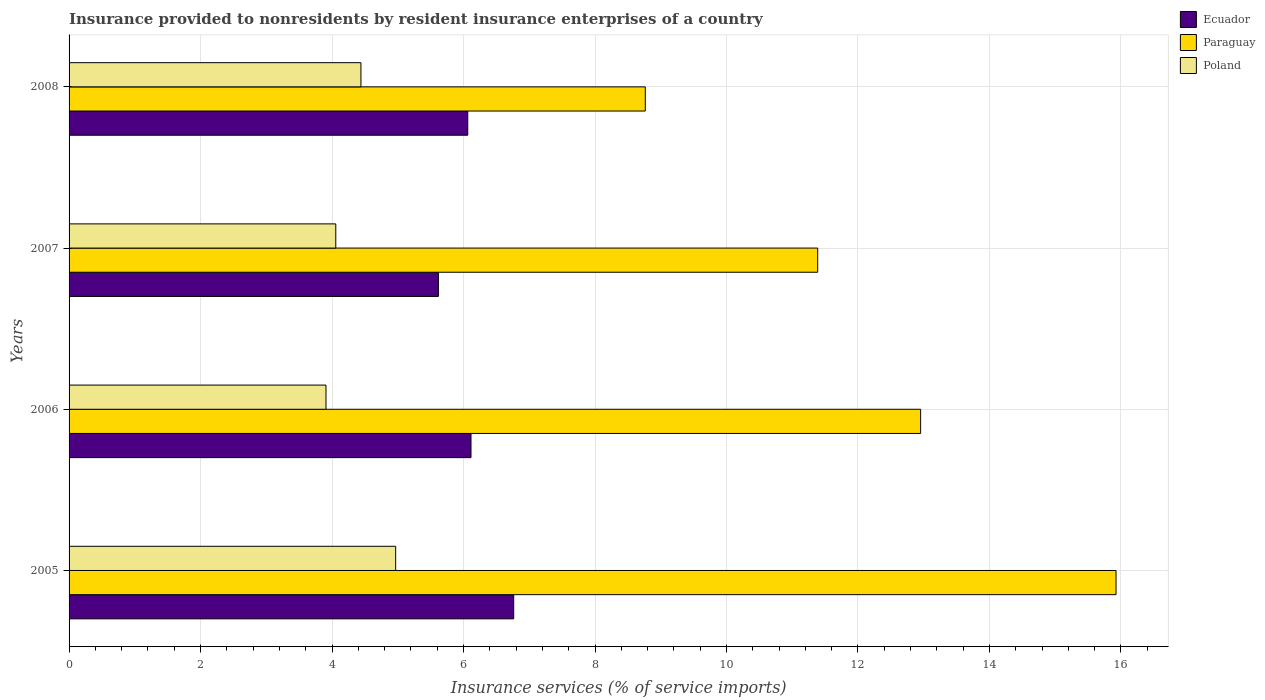How many different coloured bars are there?
Make the answer very short. 3. Are the number of bars on each tick of the Y-axis equal?
Offer a very short reply. Yes. How many bars are there on the 2nd tick from the top?
Ensure brevity in your answer.  3. What is the label of the 3rd group of bars from the top?
Your answer should be compact. 2006. In how many cases, is the number of bars for a given year not equal to the number of legend labels?
Keep it short and to the point. 0. What is the insurance provided to nonresidents in Paraguay in 2007?
Provide a succinct answer. 11.39. Across all years, what is the maximum insurance provided to nonresidents in Poland?
Give a very brief answer. 4.97. Across all years, what is the minimum insurance provided to nonresidents in Poland?
Offer a very short reply. 3.91. In which year was the insurance provided to nonresidents in Poland maximum?
Your response must be concise. 2005. What is the total insurance provided to nonresidents in Poland in the graph?
Your answer should be compact. 17.37. What is the difference between the insurance provided to nonresidents in Poland in 2006 and that in 2007?
Ensure brevity in your answer.  -0.15. What is the difference between the insurance provided to nonresidents in Poland in 2006 and the insurance provided to nonresidents in Paraguay in 2005?
Offer a terse response. -12.02. What is the average insurance provided to nonresidents in Ecuador per year?
Offer a terse response. 6.14. In the year 2008, what is the difference between the insurance provided to nonresidents in Poland and insurance provided to nonresidents in Paraguay?
Your answer should be very brief. -4.33. In how many years, is the insurance provided to nonresidents in Paraguay greater than 16 %?
Provide a succinct answer. 0. What is the ratio of the insurance provided to nonresidents in Ecuador in 2005 to that in 2006?
Ensure brevity in your answer.  1.11. Is the difference between the insurance provided to nonresidents in Poland in 2005 and 2006 greater than the difference between the insurance provided to nonresidents in Paraguay in 2005 and 2006?
Offer a terse response. No. What is the difference between the highest and the second highest insurance provided to nonresidents in Ecuador?
Give a very brief answer. 0.65. What is the difference between the highest and the lowest insurance provided to nonresidents in Ecuador?
Offer a terse response. 1.15. In how many years, is the insurance provided to nonresidents in Poland greater than the average insurance provided to nonresidents in Poland taken over all years?
Provide a short and direct response. 2. What does the 3rd bar from the top in 2007 represents?
Ensure brevity in your answer.  Ecuador. What does the 3rd bar from the bottom in 2008 represents?
Make the answer very short. Poland. How many bars are there?
Your answer should be very brief. 12. Are all the bars in the graph horizontal?
Make the answer very short. Yes. What is the difference between two consecutive major ticks on the X-axis?
Keep it short and to the point. 2. Does the graph contain grids?
Provide a short and direct response. Yes. Where does the legend appear in the graph?
Your answer should be very brief. Top right. How many legend labels are there?
Offer a terse response. 3. How are the legend labels stacked?
Ensure brevity in your answer.  Vertical. What is the title of the graph?
Your answer should be very brief. Insurance provided to nonresidents by resident insurance enterprises of a country. What is the label or title of the X-axis?
Give a very brief answer. Insurance services (% of service imports). What is the Insurance services (% of service imports) of Ecuador in 2005?
Your answer should be compact. 6.76. What is the Insurance services (% of service imports) in Paraguay in 2005?
Ensure brevity in your answer.  15.93. What is the Insurance services (% of service imports) in Poland in 2005?
Keep it short and to the point. 4.97. What is the Insurance services (% of service imports) of Ecuador in 2006?
Make the answer very short. 6.11. What is the Insurance services (% of service imports) in Paraguay in 2006?
Your response must be concise. 12.95. What is the Insurance services (% of service imports) in Poland in 2006?
Provide a succinct answer. 3.91. What is the Insurance services (% of service imports) in Ecuador in 2007?
Give a very brief answer. 5.62. What is the Insurance services (% of service imports) of Paraguay in 2007?
Offer a terse response. 11.39. What is the Insurance services (% of service imports) of Poland in 2007?
Ensure brevity in your answer.  4.06. What is the Insurance services (% of service imports) of Ecuador in 2008?
Provide a succinct answer. 6.06. What is the Insurance services (% of service imports) in Paraguay in 2008?
Offer a very short reply. 8.77. What is the Insurance services (% of service imports) in Poland in 2008?
Provide a short and direct response. 4.44. Across all years, what is the maximum Insurance services (% of service imports) in Ecuador?
Your answer should be compact. 6.76. Across all years, what is the maximum Insurance services (% of service imports) of Paraguay?
Your answer should be very brief. 15.93. Across all years, what is the maximum Insurance services (% of service imports) in Poland?
Provide a short and direct response. 4.97. Across all years, what is the minimum Insurance services (% of service imports) in Ecuador?
Give a very brief answer. 5.62. Across all years, what is the minimum Insurance services (% of service imports) in Paraguay?
Keep it short and to the point. 8.77. Across all years, what is the minimum Insurance services (% of service imports) of Poland?
Provide a short and direct response. 3.91. What is the total Insurance services (% of service imports) of Ecuador in the graph?
Offer a terse response. 24.56. What is the total Insurance services (% of service imports) in Paraguay in the graph?
Ensure brevity in your answer.  49.03. What is the total Insurance services (% of service imports) in Poland in the graph?
Give a very brief answer. 17.37. What is the difference between the Insurance services (% of service imports) in Ecuador in 2005 and that in 2006?
Offer a terse response. 0.65. What is the difference between the Insurance services (% of service imports) of Paraguay in 2005 and that in 2006?
Ensure brevity in your answer.  2.97. What is the difference between the Insurance services (% of service imports) in Poland in 2005 and that in 2006?
Provide a short and direct response. 1.06. What is the difference between the Insurance services (% of service imports) in Ecuador in 2005 and that in 2007?
Make the answer very short. 1.15. What is the difference between the Insurance services (% of service imports) of Paraguay in 2005 and that in 2007?
Offer a terse response. 4.54. What is the difference between the Insurance services (% of service imports) in Poland in 2005 and that in 2007?
Offer a terse response. 0.91. What is the difference between the Insurance services (% of service imports) in Ecuador in 2005 and that in 2008?
Give a very brief answer. 0.7. What is the difference between the Insurance services (% of service imports) of Paraguay in 2005 and that in 2008?
Offer a terse response. 7.16. What is the difference between the Insurance services (% of service imports) of Poland in 2005 and that in 2008?
Your answer should be compact. 0.53. What is the difference between the Insurance services (% of service imports) of Ecuador in 2006 and that in 2007?
Ensure brevity in your answer.  0.5. What is the difference between the Insurance services (% of service imports) of Paraguay in 2006 and that in 2007?
Make the answer very short. 1.57. What is the difference between the Insurance services (% of service imports) in Poland in 2006 and that in 2007?
Provide a short and direct response. -0.15. What is the difference between the Insurance services (% of service imports) of Ecuador in 2006 and that in 2008?
Your answer should be compact. 0.05. What is the difference between the Insurance services (% of service imports) in Paraguay in 2006 and that in 2008?
Provide a short and direct response. 4.19. What is the difference between the Insurance services (% of service imports) in Poland in 2006 and that in 2008?
Keep it short and to the point. -0.53. What is the difference between the Insurance services (% of service imports) in Ecuador in 2007 and that in 2008?
Give a very brief answer. -0.45. What is the difference between the Insurance services (% of service imports) of Paraguay in 2007 and that in 2008?
Your answer should be compact. 2.62. What is the difference between the Insurance services (% of service imports) of Poland in 2007 and that in 2008?
Offer a terse response. -0.38. What is the difference between the Insurance services (% of service imports) of Ecuador in 2005 and the Insurance services (% of service imports) of Paraguay in 2006?
Your answer should be compact. -6.19. What is the difference between the Insurance services (% of service imports) in Ecuador in 2005 and the Insurance services (% of service imports) in Poland in 2006?
Provide a succinct answer. 2.86. What is the difference between the Insurance services (% of service imports) of Paraguay in 2005 and the Insurance services (% of service imports) of Poland in 2006?
Provide a succinct answer. 12.02. What is the difference between the Insurance services (% of service imports) of Ecuador in 2005 and the Insurance services (% of service imports) of Paraguay in 2007?
Your response must be concise. -4.62. What is the difference between the Insurance services (% of service imports) in Ecuador in 2005 and the Insurance services (% of service imports) in Poland in 2007?
Make the answer very short. 2.71. What is the difference between the Insurance services (% of service imports) in Paraguay in 2005 and the Insurance services (% of service imports) in Poland in 2007?
Give a very brief answer. 11.87. What is the difference between the Insurance services (% of service imports) of Ecuador in 2005 and the Insurance services (% of service imports) of Paraguay in 2008?
Your answer should be compact. -2. What is the difference between the Insurance services (% of service imports) in Ecuador in 2005 and the Insurance services (% of service imports) in Poland in 2008?
Your answer should be very brief. 2.32. What is the difference between the Insurance services (% of service imports) in Paraguay in 2005 and the Insurance services (% of service imports) in Poland in 2008?
Ensure brevity in your answer.  11.49. What is the difference between the Insurance services (% of service imports) in Ecuador in 2006 and the Insurance services (% of service imports) in Paraguay in 2007?
Your answer should be very brief. -5.27. What is the difference between the Insurance services (% of service imports) of Ecuador in 2006 and the Insurance services (% of service imports) of Poland in 2007?
Provide a succinct answer. 2.06. What is the difference between the Insurance services (% of service imports) in Paraguay in 2006 and the Insurance services (% of service imports) in Poland in 2007?
Offer a terse response. 8.9. What is the difference between the Insurance services (% of service imports) in Ecuador in 2006 and the Insurance services (% of service imports) in Paraguay in 2008?
Your answer should be compact. -2.65. What is the difference between the Insurance services (% of service imports) of Ecuador in 2006 and the Insurance services (% of service imports) of Poland in 2008?
Your response must be concise. 1.67. What is the difference between the Insurance services (% of service imports) in Paraguay in 2006 and the Insurance services (% of service imports) in Poland in 2008?
Offer a terse response. 8.51. What is the difference between the Insurance services (% of service imports) of Ecuador in 2007 and the Insurance services (% of service imports) of Paraguay in 2008?
Offer a terse response. -3.15. What is the difference between the Insurance services (% of service imports) in Ecuador in 2007 and the Insurance services (% of service imports) in Poland in 2008?
Keep it short and to the point. 1.18. What is the difference between the Insurance services (% of service imports) in Paraguay in 2007 and the Insurance services (% of service imports) in Poland in 2008?
Keep it short and to the point. 6.95. What is the average Insurance services (% of service imports) of Ecuador per year?
Your answer should be compact. 6.14. What is the average Insurance services (% of service imports) in Paraguay per year?
Offer a terse response. 12.26. What is the average Insurance services (% of service imports) of Poland per year?
Give a very brief answer. 4.34. In the year 2005, what is the difference between the Insurance services (% of service imports) of Ecuador and Insurance services (% of service imports) of Paraguay?
Your answer should be very brief. -9.16. In the year 2005, what is the difference between the Insurance services (% of service imports) of Ecuador and Insurance services (% of service imports) of Poland?
Provide a short and direct response. 1.8. In the year 2005, what is the difference between the Insurance services (% of service imports) of Paraguay and Insurance services (% of service imports) of Poland?
Your answer should be compact. 10.96. In the year 2006, what is the difference between the Insurance services (% of service imports) in Ecuador and Insurance services (% of service imports) in Paraguay?
Your answer should be very brief. -6.84. In the year 2006, what is the difference between the Insurance services (% of service imports) in Ecuador and Insurance services (% of service imports) in Poland?
Provide a short and direct response. 2.21. In the year 2006, what is the difference between the Insurance services (% of service imports) in Paraguay and Insurance services (% of service imports) in Poland?
Make the answer very short. 9.04. In the year 2007, what is the difference between the Insurance services (% of service imports) of Ecuador and Insurance services (% of service imports) of Paraguay?
Provide a succinct answer. -5.77. In the year 2007, what is the difference between the Insurance services (% of service imports) of Ecuador and Insurance services (% of service imports) of Poland?
Ensure brevity in your answer.  1.56. In the year 2007, what is the difference between the Insurance services (% of service imports) in Paraguay and Insurance services (% of service imports) in Poland?
Make the answer very short. 7.33. In the year 2008, what is the difference between the Insurance services (% of service imports) of Ecuador and Insurance services (% of service imports) of Paraguay?
Keep it short and to the point. -2.7. In the year 2008, what is the difference between the Insurance services (% of service imports) in Ecuador and Insurance services (% of service imports) in Poland?
Keep it short and to the point. 1.62. In the year 2008, what is the difference between the Insurance services (% of service imports) of Paraguay and Insurance services (% of service imports) of Poland?
Ensure brevity in your answer.  4.33. What is the ratio of the Insurance services (% of service imports) in Ecuador in 2005 to that in 2006?
Your answer should be very brief. 1.11. What is the ratio of the Insurance services (% of service imports) of Paraguay in 2005 to that in 2006?
Give a very brief answer. 1.23. What is the ratio of the Insurance services (% of service imports) of Poland in 2005 to that in 2006?
Keep it short and to the point. 1.27. What is the ratio of the Insurance services (% of service imports) in Ecuador in 2005 to that in 2007?
Offer a very short reply. 1.2. What is the ratio of the Insurance services (% of service imports) of Paraguay in 2005 to that in 2007?
Your response must be concise. 1.4. What is the ratio of the Insurance services (% of service imports) in Poland in 2005 to that in 2007?
Provide a short and direct response. 1.22. What is the ratio of the Insurance services (% of service imports) of Ecuador in 2005 to that in 2008?
Provide a succinct answer. 1.12. What is the ratio of the Insurance services (% of service imports) in Paraguay in 2005 to that in 2008?
Give a very brief answer. 1.82. What is the ratio of the Insurance services (% of service imports) of Poland in 2005 to that in 2008?
Provide a succinct answer. 1.12. What is the ratio of the Insurance services (% of service imports) in Ecuador in 2006 to that in 2007?
Ensure brevity in your answer.  1.09. What is the ratio of the Insurance services (% of service imports) of Paraguay in 2006 to that in 2007?
Offer a terse response. 1.14. What is the ratio of the Insurance services (% of service imports) of Poland in 2006 to that in 2007?
Ensure brevity in your answer.  0.96. What is the ratio of the Insurance services (% of service imports) of Ecuador in 2006 to that in 2008?
Make the answer very short. 1.01. What is the ratio of the Insurance services (% of service imports) of Paraguay in 2006 to that in 2008?
Offer a terse response. 1.48. What is the ratio of the Insurance services (% of service imports) of Poland in 2006 to that in 2008?
Provide a succinct answer. 0.88. What is the ratio of the Insurance services (% of service imports) of Ecuador in 2007 to that in 2008?
Give a very brief answer. 0.93. What is the ratio of the Insurance services (% of service imports) in Paraguay in 2007 to that in 2008?
Your response must be concise. 1.3. What is the ratio of the Insurance services (% of service imports) of Poland in 2007 to that in 2008?
Ensure brevity in your answer.  0.91. What is the difference between the highest and the second highest Insurance services (% of service imports) of Ecuador?
Your answer should be compact. 0.65. What is the difference between the highest and the second highest Insurance services (% of service imports) of Paraguay?
Provide a succinct answer. 2.97. What is the difference between the highest and the second highest Insurance services (% of service imports) of Poland?
Your response must be concise. 0.53. What is the difference between the highest and the lowest Insurance services (% of service imports) in Ecuador?
Ensure brevity in your answer.  1.15. What is the difference between the highest and the lowest Insurance services (% of service imports) of Paraguay?
Your response must be concise. 7.16. What is the difference between the highest and the lowest Insurance services (% of service imports) of Poland?
Give a very brief answer. 1.06. 